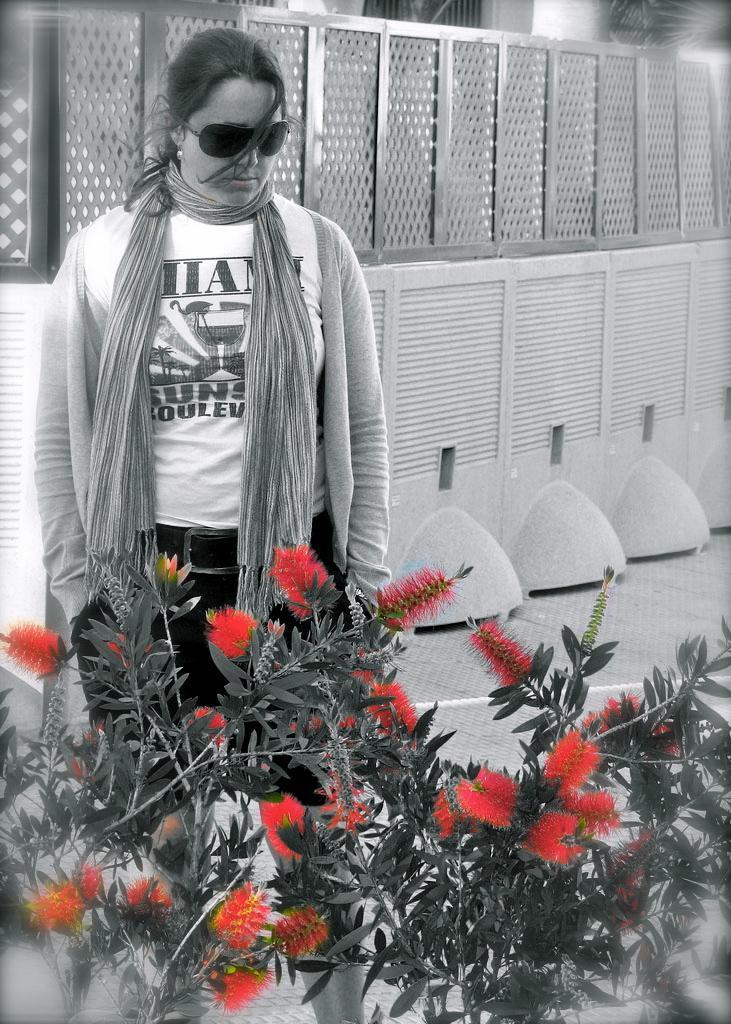Can you describe this image briefly? This is a black and white pic. We can see plants with red color flowers and a woman is standing. In the background we can see plants, wall and objects. 